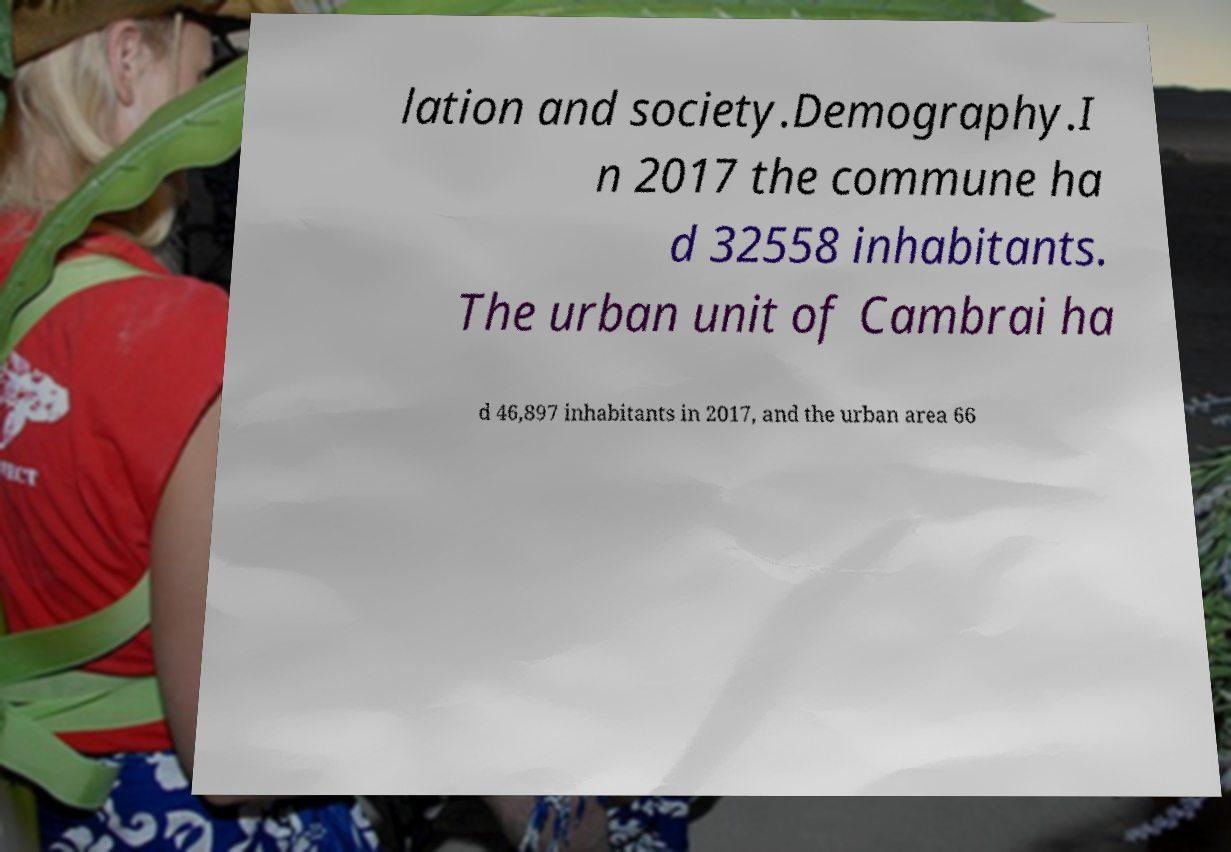Could you extract and type out the text from this image? lation and society.Demography.I n 2017 the commune ha d 32558 inhabitants. The urban unit of Cambrai ha d 46,897 inhabitants in 2017, and the urban area 66 